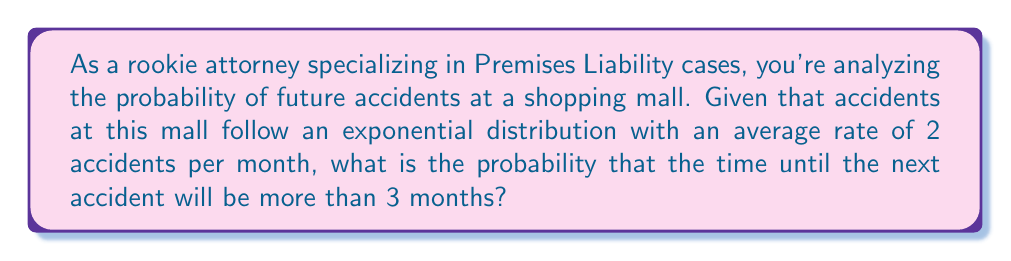Teach me how to tackle this problem. To solve this problem, we'll use the exponential distribution, which is often used to model the time between events in a Poisson process. The probability density function of the exponential distribution is:

$$f(x) = \lambda e^{-\lambda x}$$

Where $\lambda$ is the rate parameter, which is the reciprocal of the mean time between events.

Given:
- Average rate of accidents: 2 per month
- We want to find the probability of more than 3 months until the next accident

Step 1: Calculate $\lambda$
$\lambda = 2$ accidents/month

Step 2: We need to find $P(X > 3)$, where $X$ is the time until the next accident.

For the exponential distribution, the cumulative distribution function is:

$$F(x) = 1 - e^{-\lambda x}$$

And $P(X > x) = 1 - F(x) = e^{-\lambda x}$

Step 3: Calculate the probability
$$P(X > 3) = e^{-\lambda \cdot 3} = e^{-2 \cdot 3} = e^{-6}$$

Step 4: Evaluate the expression
$$e^{-6} \approx 0.00248$$

Therefore, the probability that the time until the next accident will be more than 3 months is approximately 0.00248 or 0.248%.
Answer: The probability that the time until the next accident will be more than 3 months is $e^{-6} \approx 0.00248$ or 0.248%. 